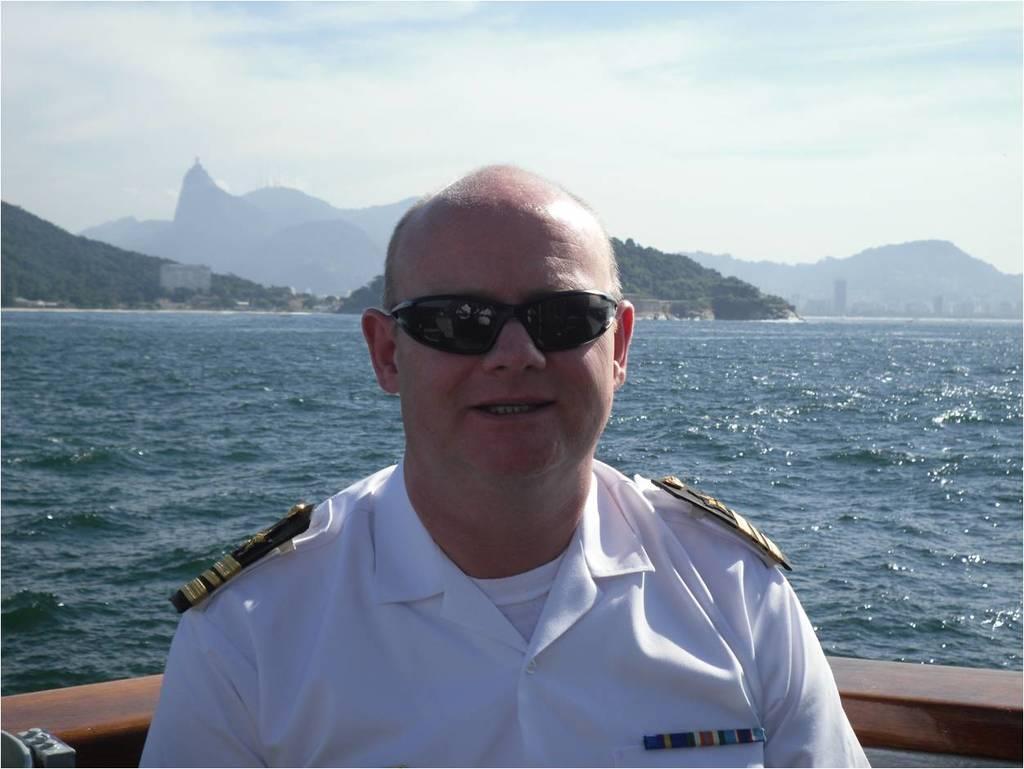How would you summarize this image in a sentence or two? In this image person is sitting on the boat. At the background there are mountains, trees, buildings, water. At the top of the image there is sky. 